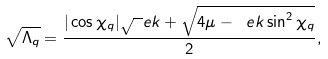Convert formula to latex. <formula><loc_0><loc_0><loc_500><loc_500>\sqrt { \Lambda _ { q } } = \frac { | \cos \chi _ { q } | \sqrt { \ } e k + \sqrt { 4 \mu - \ e k \sin ^ { 2 } \chi _ { q } } } 2 ,</formula> 